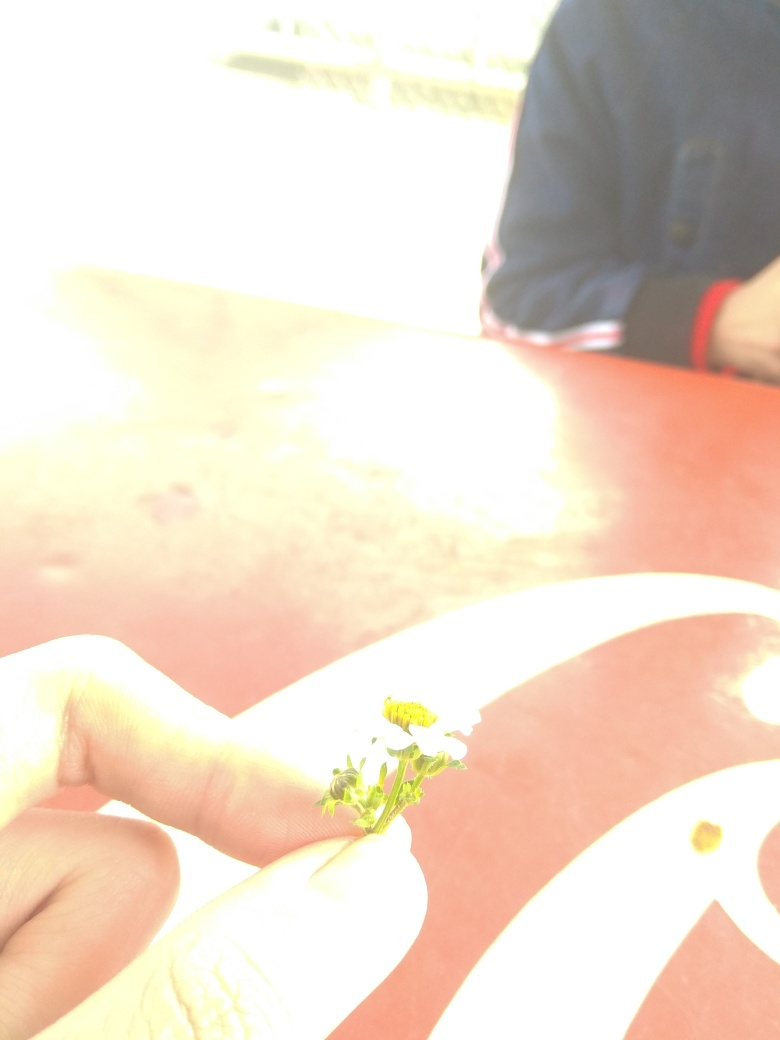How does the quality of the image affect its interpretation? The overexposure of the image greatly affects its interpretation, as it obscures background details which could provide context. The focus on the hand and flower is emphasized by the brightness, perhaps unintentionally creating a visual metaphor for a spotlight on human interaction with nature. However, this same overexposure makes it challenging to analyze the setting or atmosphere fully, thus leaving much to the viewer’s imagination. 